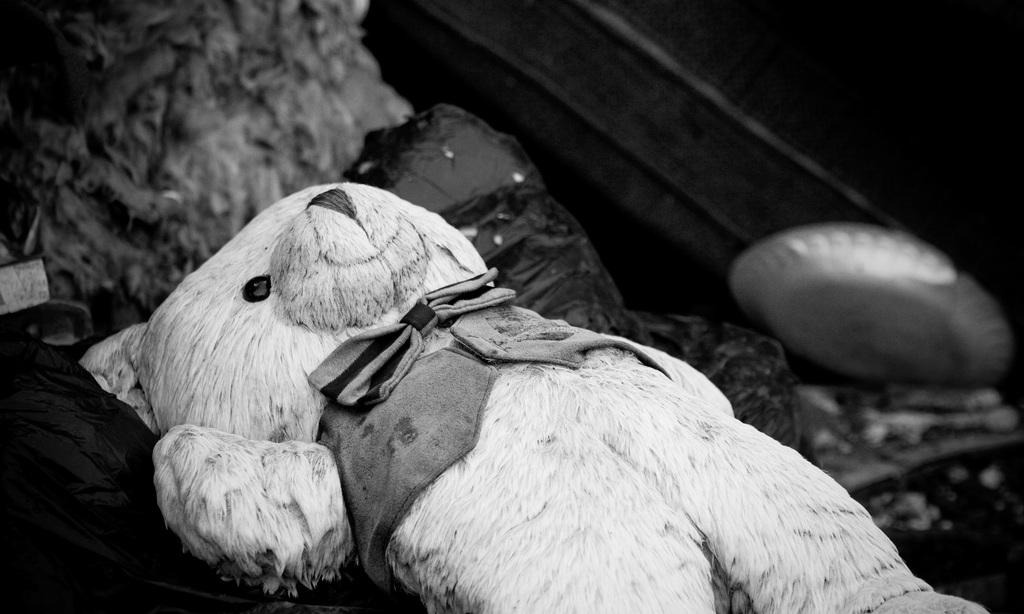What is the color scheme of the image? The image is black and white. What object can be seen in the image? There is a teddy bear in the image. What is the teddy bear placed on? The teddy bear is on a black plastic bag. Can you describe the items in the image? There are items in the image, but their specific nature is not mentioned in the facts. What color is the background of the image? The background of the image is black. How many flowers are present in the image? There are no flowers present in the image. What is the size of the teddy bear in the image? The size of the teddy bear is not mentioned in the facts, so it cannot be determined from the image. 